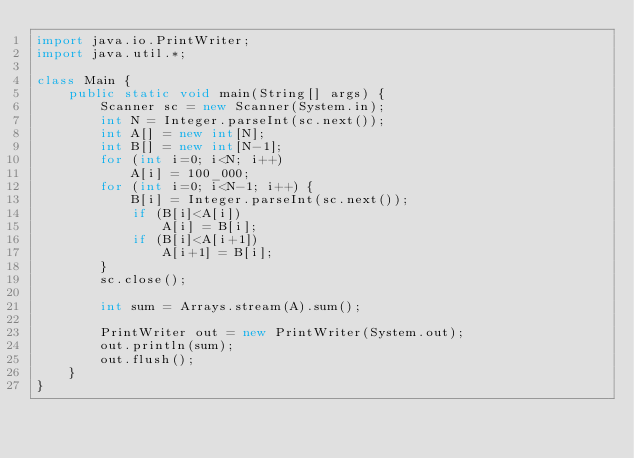<code> <loc_0><loc_0><loc_500><loc_500><_Java_>import java.io.PrintWriter;
import java.util.*;

class Main {
    public static void main(String[] args) {
        Scanner sc = new Scanner(System.in);
        int N = Integer.parseInt(sc.next());
        int A[] = new int[N];
        int B[] = new int[N-1];
        for (int i=0; i<N; i++)
            A[i] = 100_000;
        for (int i=0; i<N-1; i++) {
            B[i] = Integer.parseInt(sc.next());
            if (B[i]<A[i])
                A[i] = B[i];
            if (B[i]<A[i+1])
                A[i+1] = B[i];
        }
        sc.close();

        int sum = Arrays.stream(A).sum();

        PrintWriter out = new PrintWriter(System.out);
        out.println(sum);
        out.flush();
    }
}</code> 